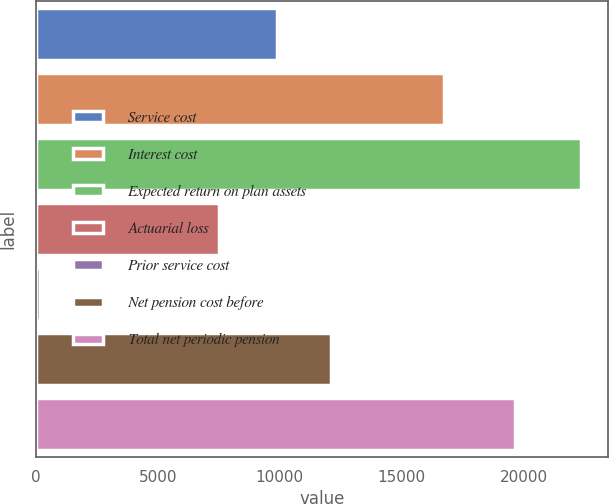Convert chart to OTSL. <chart><loc_0><loc_0><loc_500><loc_500><bar_chart><fcel>Service cost<fcel>Interest cost<fcel>Expected return on plan assets<fcel>Actuarial loss<fcel>Prior service cost<fcel>Net pension cost before<fcel>Total net periodic pension<nl><fcel>9875<fcel>16746<fcel>22368<fcel>7512<fcel>176<fcel>12094.2<fcel>19650<nl></chart> 